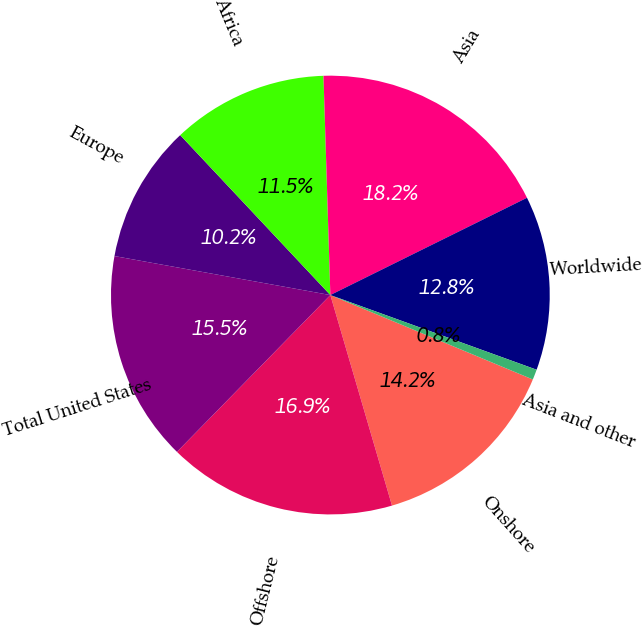Convert chart. <chart><loc_0><loc_0><loc_500><loc_500><pie_chart><fcel>Onshore<fcel>Offshore<fcel>Total United States<fcel>Europe<fcel>Africa<fcel>Asia<fcel>Worldwide<fcel>Asia and other<nl><fcel>14.18%<fcel>16.86%<fcel>15.52%<fcel>10.16%<fcel>11.5%<fcel>18.19%<fcel>12.84%<fcel>0.76%<nl></chart> 